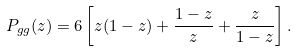Convert formula to latex. <formula><loc_0><loc_0><loc_500><loc_500>P _ { g g } ( z ) = 6 \left [ z ( 1 - z ) + \frac { 1 - z } { z } + \frac { z } { 1 - z } \right ] .</formula> 